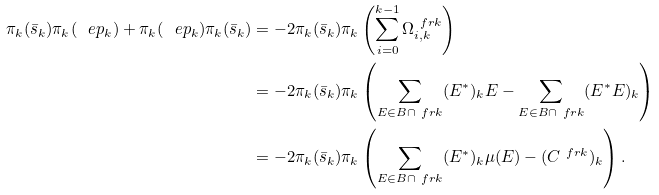<formula> <loc_0><loc_0><loc_500><loc_500>\pi _ { k } ( \bar { s } _ { k } ) \pi _ { k } ( \ e p _ { k } ) + \pi _ { k } ( \ e p _ { k } ) \pi _ { k } ( \bar { s } _ { k } ) & = - 2 \pi _ { k } ( \bar { s } _ { k } ) \pi _ { k } \left ( \sum _ { i = 0 } ^ { k - 1 } \Omega _ { i , k } ^ { \ f r k } \right ) \\ & = - 2 \pi _ { k } ( \bar { s } _ { k } ) \pi _ { k } \left ( \sum _ { E \in B \cap \ f r k } ( E ^ { * } ) _ { k } E - \sum _ { E \in B \cap \ f r k } ( E ^ { * } E ) _ { k } \right ) \\ & = - 2 \pi _ { k } ( \bar { s } _ { k } ) \pi _ { k } \left ( \sum _ { E \in B \cap \ f r k } ( E ^ { * } ) _ { k } \mu ( E ) - ( C ^ { \ f r k } ) _ { k } \right ) .</formula> 